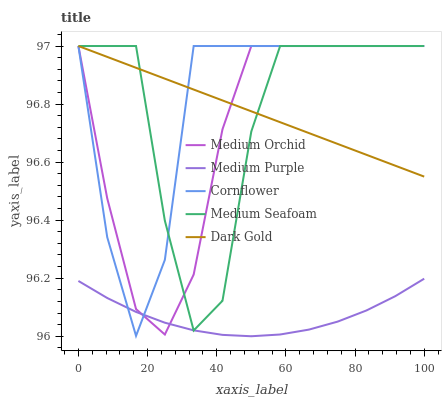Does Medium Purple have the minimum area under the curve?
Answer yes or no. Yes. Does Cornflower have the maximum area under the curve?
Answer yes or no. Yes. Does Medium Orchid have the minimum area under the curve?
Answer yes or no. No. Does Medium Orchid have the maximum area under the curve?
Answer yes or no. No. Is Dark Gold the smoothest?
Answer yes or no. Yes. Is Medium Seafoam the roughest?
Answer yes or no. Yes. Is Cornflower the smoothest?
Answer yes or no. No. Is Cornflower the roughest?
Answer yes or no. No. Does Medium Purple have the lowest value?
Answer yes or no. Yes. Does Cornflower have the lowest value?
Answer yes or no. No. Does Dark Gold have the highest value?
Answer yes or no. Yes. Is Medium Purple less than Dark Gold?
Answer yes or no. Yes. Is Dark Gold greater than Medium Purple?
Answer yes or no. Yes. Does Medium Purple intersect Medium Orchid?
Answer yes or no. Yes. Is Medium Purple less than Medium Orchid?
Answer yes or no. No. Is Medium Purple greater than Medium Orchid?
Answer yes or no. No. Does Medium Purple intersect Dark Gold?
Answer yes or no. No. 